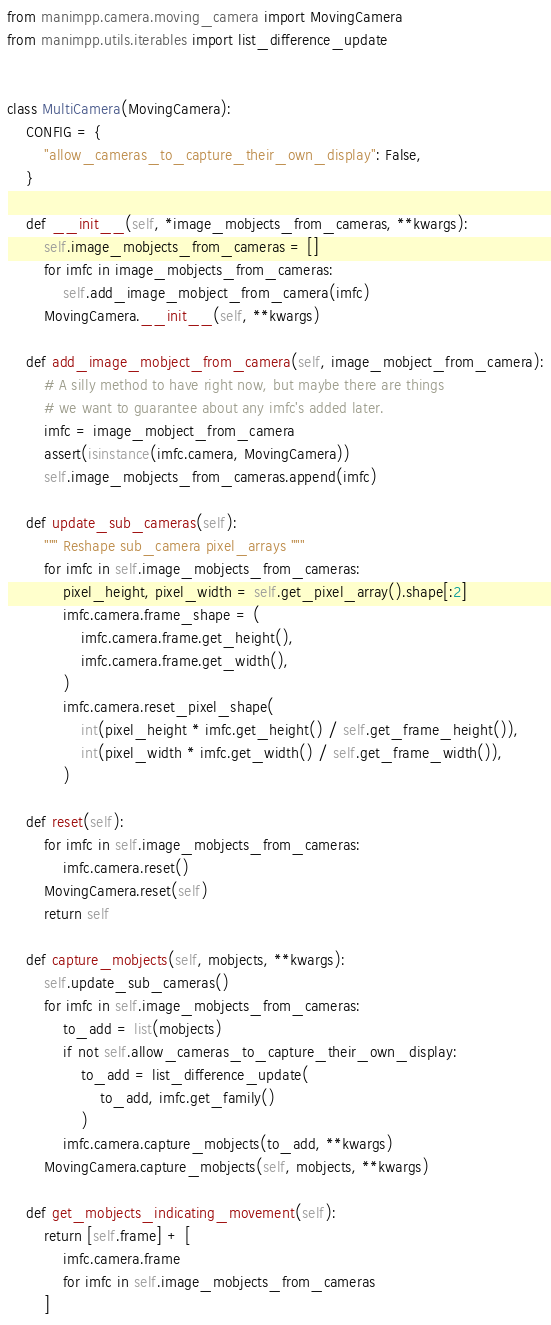Convert code to text. <code><loc_0><loc_0><loc_500><loc_500><_Python_>from manimpp.camera.moving_camera import MovingCamera
from manimpp.utils.iterables import list_difference_update


class MultiCamera(MovingCamera):
    CONFIG = {
        "allow_cameras_to_capture_their_own_display": False,
    }

    def __init__(self, *image_mobjects_from_cameras, **kwargs):
        self.image_mobjects_from_cameras = []
        for imfc in image_mobjects_from_cameras:
            self.add_image_mobject_from_camera(imfc)
        MovingCamera.__init__(self, **kwargs)

    def add_image_mobject_from_camera(self, image_mobject_from_camera):
        # A silly method to have right now, but maybe there are things
        # we want to guarantee about any imfc's added later.
        imfc = image_mobject_from_camera
        assert(isinstance(imfc.camera, MovingCamera))
        self.image_mobjects_from_cameras.append(imfc)

    def update_sub_cameras(self):
        """ Reshape sub_camera pixel_arrays """
        for imfc in self.image_mobjects_from_cameras:
            pixel_height, pixel_width = self.get_pixel_array().shape[:2]
            imfc.camera.frame_shape = (
                imfc.camera.frame.get_height(),
                imfc.camera.frame.get_width(),
            )
            imfc.camera.reset_pixel_shape(
                int(pixel_height * imfc.get_height() / self.get_frame_height()),
                int(pixel_width * imfc.get_width() / self.get_frame_width()),
            )

    def reset(self):
        for imfc in self.image_mobjects_from_cameras:
            imfc.camera.reset()
        MovingCamera.reset(self)
        return self

    def capture_mobjects(self, mobjects, **kwargs):
        self.update_sub_cameras()
        for imfc in self.image_mobjects_from_cameras:
            to_add = list(mobjects)
            if not self.allow_cameras_to_capture_their_own_display:
                to_add = list_difference_update(
                    to_add, imfc.get_family()
                )
            imfc.camera.capture_mobjects(to_add, **kwargs)
        MovingCamera.capture_mobjects(self, mobjects, **kwargs)

    def get_mobjects_indicating_movement(self):
        return [self.frame] + [
            imfc.camera.frame
            for imfc in self.image_mobjects_from_cameras
        ]
</code> 